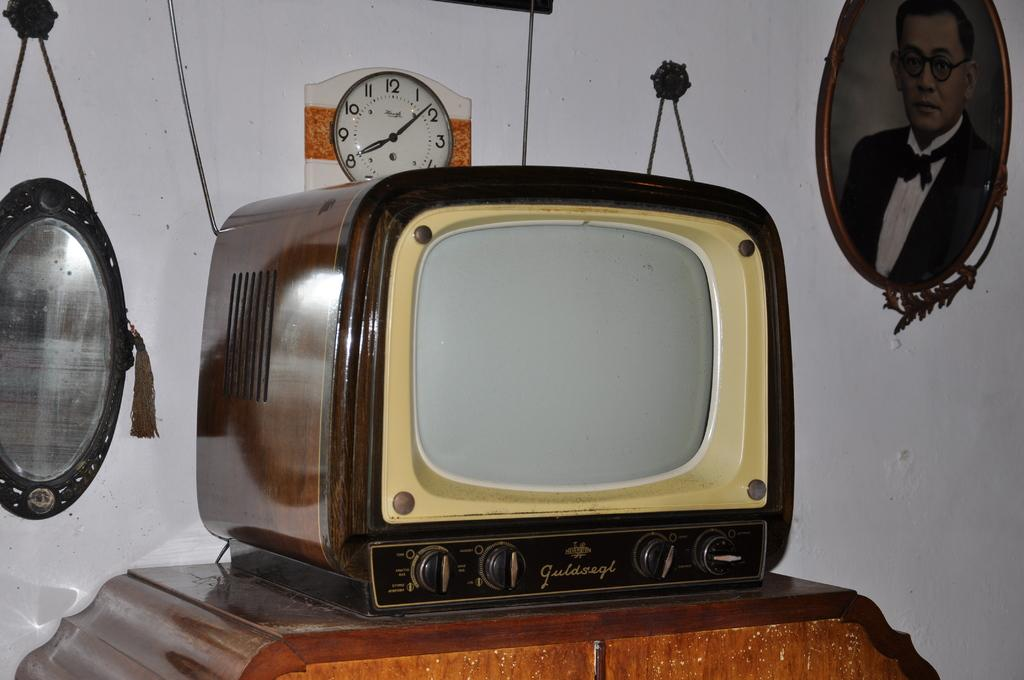<image>
Relay a brief, clear account of the picture shown. a clock that has the number 12 at the top behind a t.v 